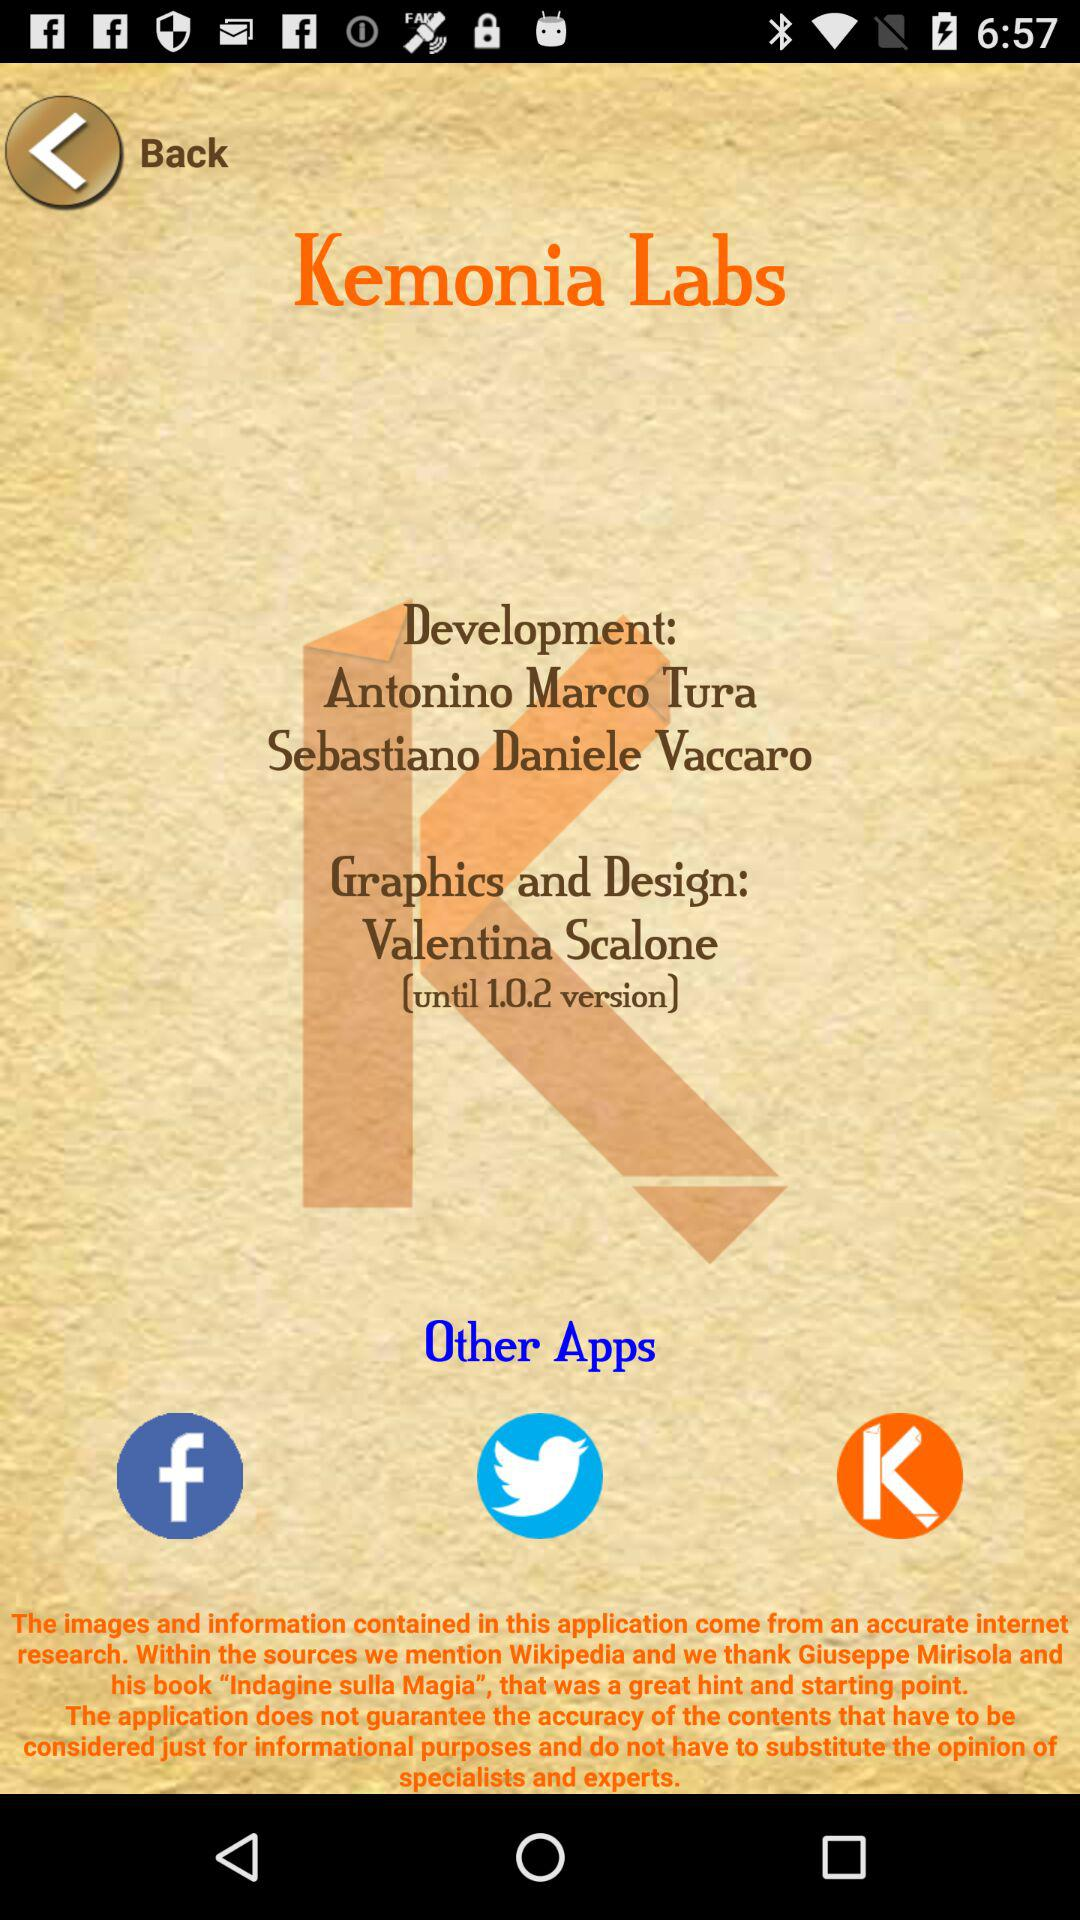Which version is used? The used version is 1.0.2. 